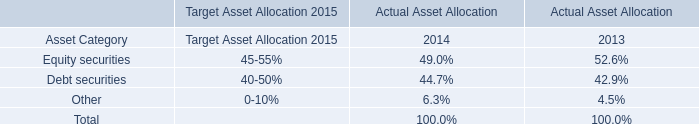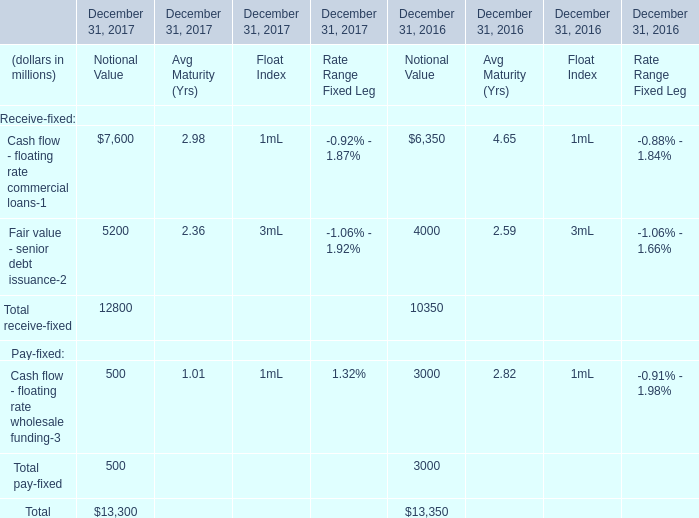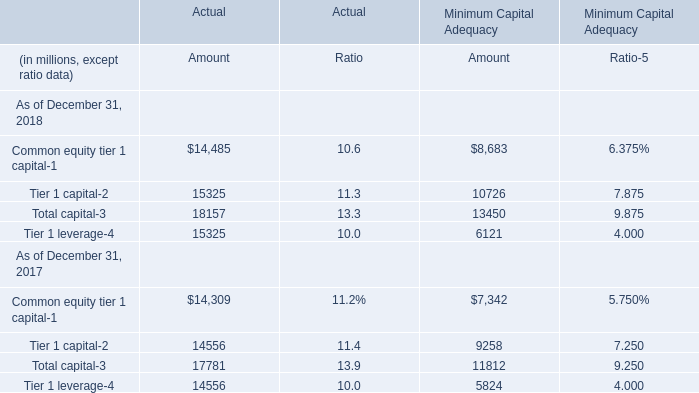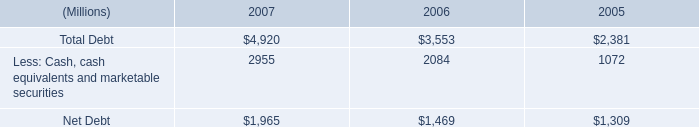In the year with lowest amount of Total receive-fixed, what's the increasing rate of Total pay-fixed? 
Computations: ((3000 - 500) / 3000)
Answer: 0.83333. 